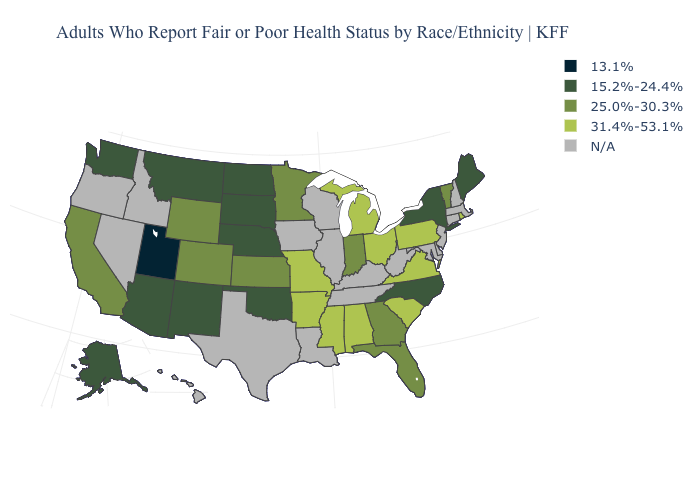Name the states that have a value in the range N/A?
Write a very short answer. Connecticut, Delaware, Hawaii, Idaho, Illinois, Iowa, Kentucky, Louisiana, Maryland, Massachusetts, Nevada, New Hampshire, New Jersey, Oregon, Tennessee, Texas, West Virginia, Wisconsin. Name the states that have a value in the range 25.0%-30.3%?
Quick response, please. California, Colorado, Florida, Georgia, Indiana, Kansas, Minnesota, Vermont, Wyoming. What is the value of Kansas?
Keep it brief. 25.0%-30.3%. Name the states that have a value in the range 15.2%-24.4%?
Quick response, please. Alaska, Arizona, Maine, Montana, Nebraska, New Mexico, New York, North Carolina, North Dakota, Oklahoma, South Dakota, Washington. What is the value of Ohio?
Write a very short answer. 31.4%-53.1%. Does the first symbol in the legend represent the smallest category?
Keep it brief. Yes. What is the lowest value in states that border Wyoming?
Give a very brief answer. 13.1%. Name the states that have a value in the range 25.0%-30.3%?
Be succinct. California, Colorado, Florida, Georgia, Indiana, Kansas, Minnesota, Vermont, Wyoming. Among the states that border Connecticut , does Rhode Island have the lowest value?
Write a very short answer. No. Among the states that border Indiana , which have the lowest value?
Quick response, please. Michigan, Ohio. Name the states that have a value in the range 13.1%?
Keep it brief. Utah. What is the value of South Carolina?
Short answer required. 31.4%-53.1%. What is the value of Louisiana?
Keep it brief. N/A. 